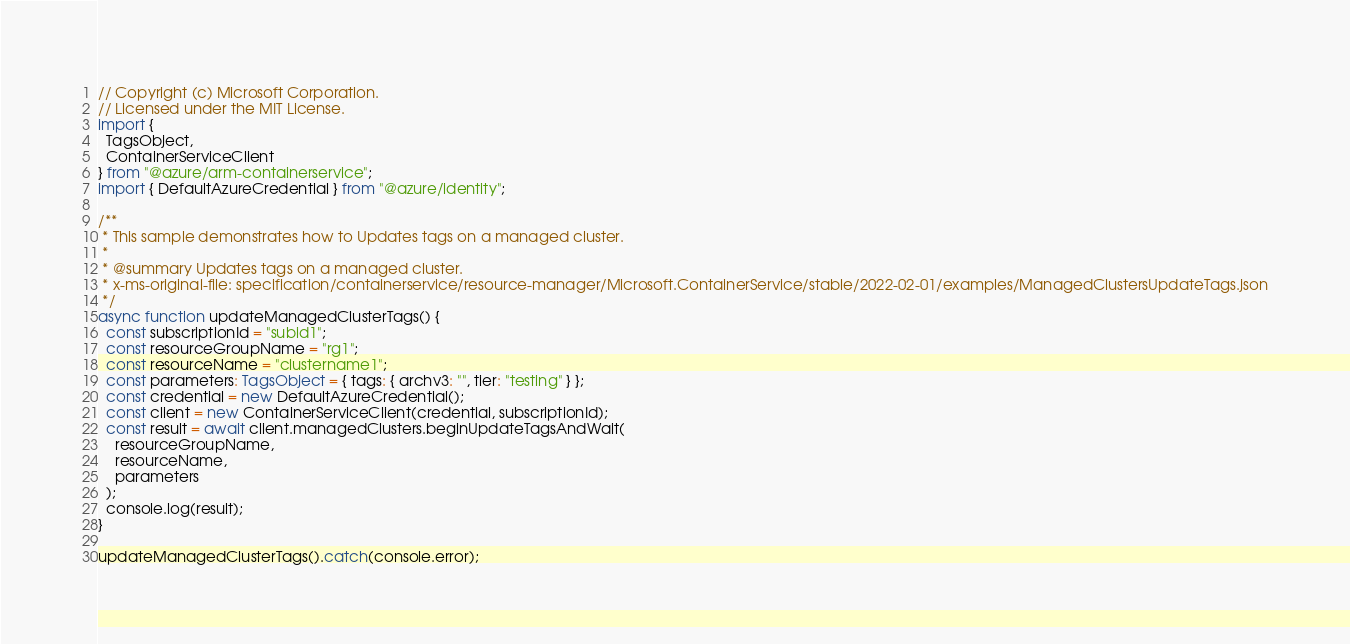Convert code to text. <code><loc_0><loc_0><loc_500><loc_500><_TypeScript_>
// Copyright (c) Microsoft Corporation.
// Licensed under the MIT License.
import {
  TagsObject,
  ContainerServiceClient
} from "@azure/arm-containerservice";
import { DefaultAzureCredential } from "@azure/identity";

/**
 * This sample demonstrates how to Updates tags on a managed cluster.
 *
 * @summary Updates tags on a managed cluster.
 * x-ms-original-file: specification/containerservice/resource-manager/Microsoft.ContainerService/stable/2022-02-01/examples/ManagedClustersUpdateTags.json
 */
async function updateManagedClusterTags() {
  const subscriptionId = "subid1";
  const resourceGroupName = "rg1";
  const resourceName = "clustername1";
  const parameters: TagsObject = { tags: { archv3: "", tier: "testing" } };
  const credential = new DefaultAzureCredential();
  const client = new ContainerServiceClient(credential, subscriptionId);
  const result = await client.managedClusters.beginUpdateTagsAndWait(
    resourceGroupName,
    resourceName,
    parameters
  );
  console.log(result);
}

updateManagedClusterTags().catch(console.error);
</code> 